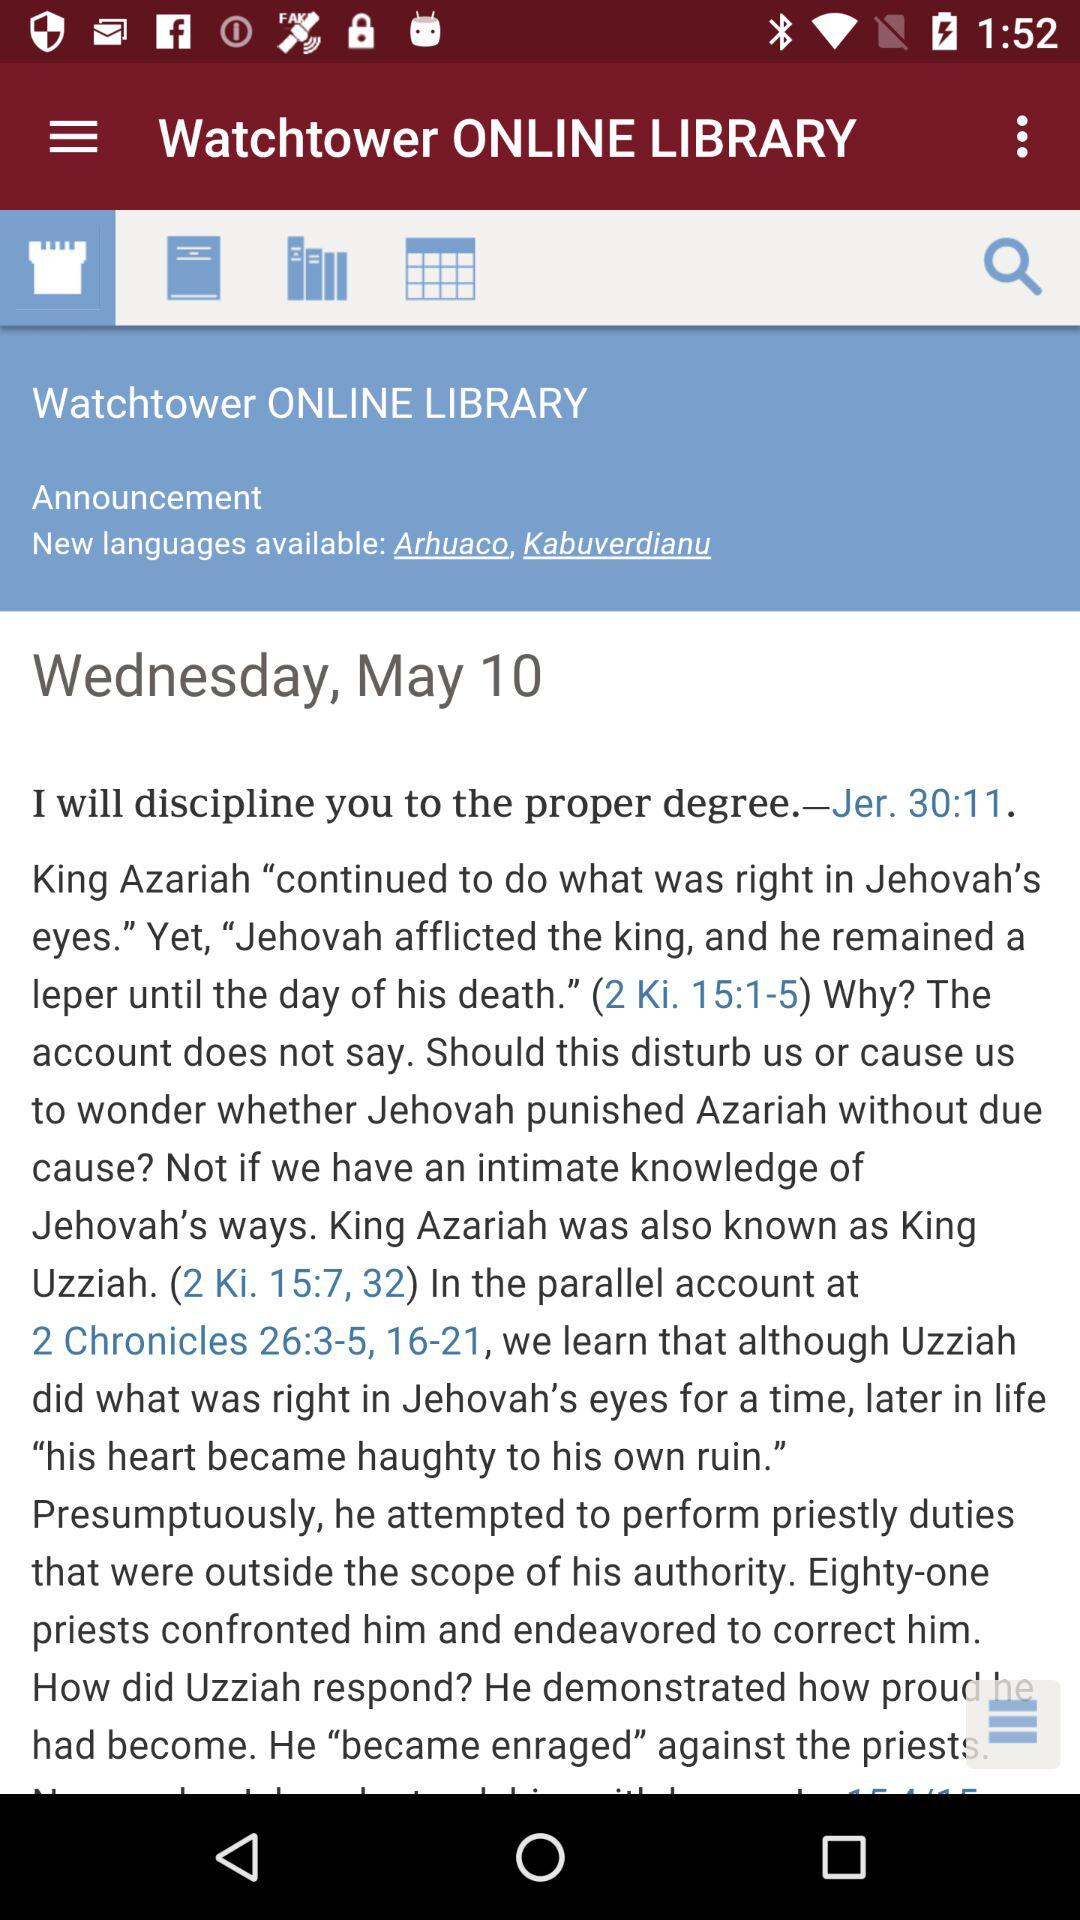What is the day on May 10? The day on May 10 is Wednesday. 